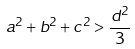<formula> <loc_0><loc_0><loc_500><loc_500>a ^ { 2 } + b ^ { 2 } + c ^ { 2 } > \frac { d ^ { 2 } } { 3 }</formula> 